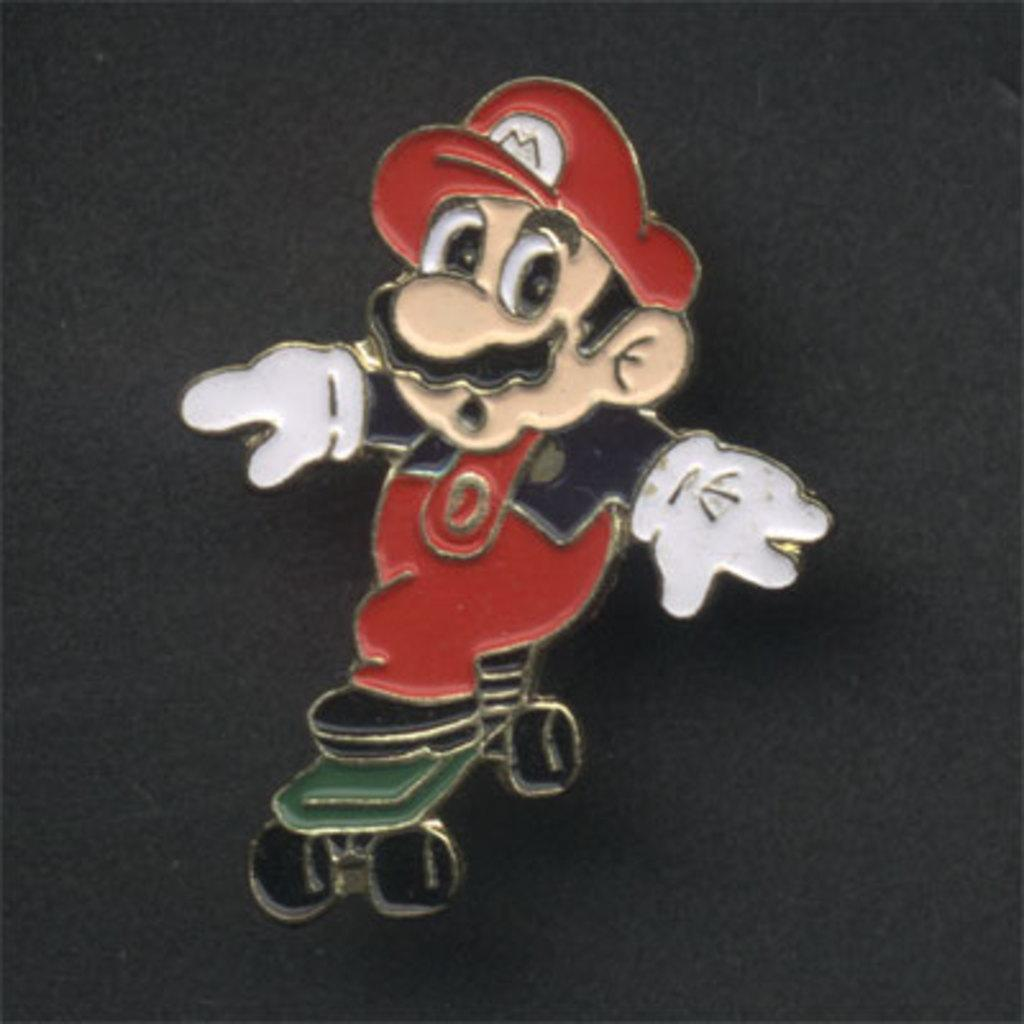What is depicted in the center of the image? There is a sticker of a cartoon in the center of the image. On what type of surface is the sticker placed? The sticker is placed on a surface. How many ants can be seen crawling on the prison in the image? There is no prison or ants present in the image; it features a sticker of a cartoon. What part of the brain is depicted on the sticker in the image? There is no depiction of a brain on the sticker in the image; it is a cartoon character. 